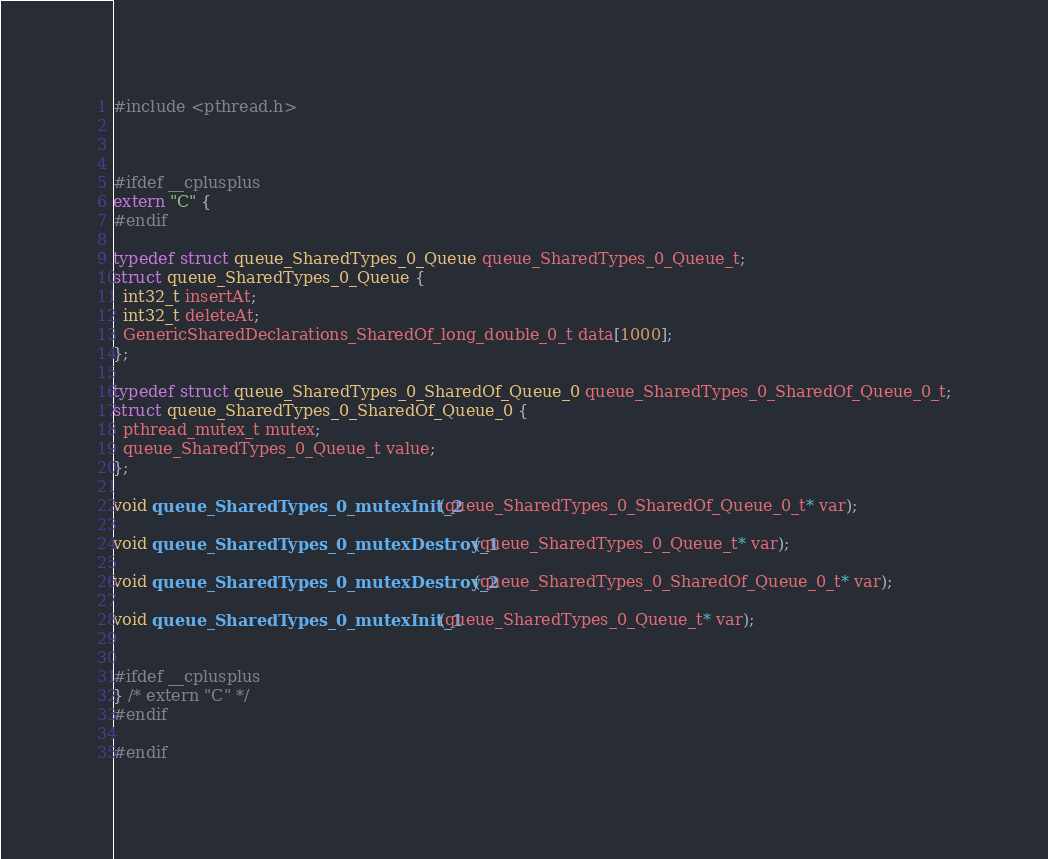Convert code to text. <code><loc_0><loc_0><loc_500><loc_500><_C_>#include <pthread.h>



#ifdef __cplusplus
extern "C" {
#endif

typedef struct queue_SharedTypes_0_Queue queue_SharedTypes_0_Queue_t;
struct queue_SharedTypes_0_Queue {
  int32_t insertAt;
  int32_t deleteAt;
  GenericSharedDeclarations_SharedOf_long_double_0_t data[1000];
};

typedef struct queue_SharedTypes_0_SharedOf_Queue_0 queue_SharedTypes_0_SharedOf_Queue_0_t;
struct queue_SharedTypes_0_SharedOf_Queue_0 {
  pthread_mutex_t mutex;
  queue_SharedTypes_0_Queue_t value;
};

void queue_SharedTypes_0_mutexInit_2(queue_SharedTypes_0_SharedOf_Queue_0_t* var);

void queue_SharedTypes_0_mutexDestroy_1(queue_SharedTypes_0_Queue_t* var);

void queue_SharedTypes_0_mutexDestroy_2(queue_SharedTypes_0_SharedOf_Queue_0_t* var);

void queue_SharedTypes_0_mutexInit_1(queue_SharedTypes_0_Queue_t* var);


#ifdef __cplusplus
} /* extern "C" */
#endif

#endif
</code> 